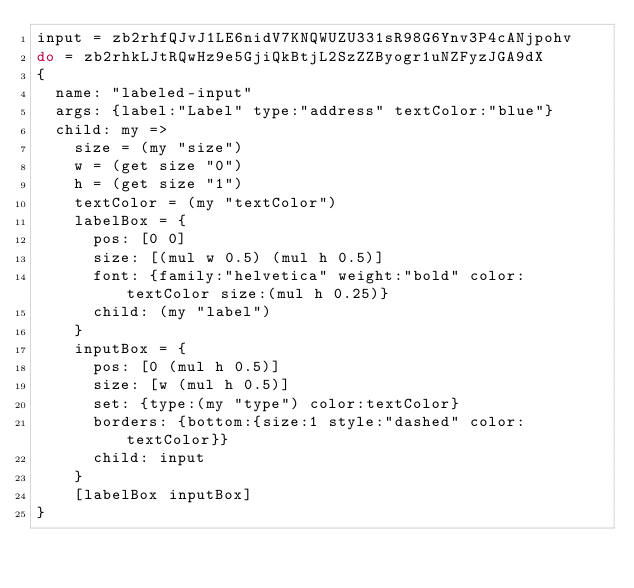<code> <loc_0><loc_0><loc_500><loc_500><_MoonScript_>input = zb2rhfQJvJ1LE6nidV7KNQWUZU331sR98G6Ynv3P4cANjpohv
do = zb2rhkLJtRQwHz9e5GjiQkBtjL2SzZZByogr1uNZFyzJGA9dX
{
  name: "labeled-input"
  args: {label:"Label" type:"address" textColor:"blue"}
  child: my =>
    size = (my "size")
    w = (get size "0")
    h = (get size "1")
    textColor = (my "textColor")
    labelBox = {
      pos: [0 0]
      size: [(mul w 0.5) (mul h 0.5)]
      font: {family:"helvetica" weight:"bold" color:textColor size:(mul h 0.25)}
      child: (my "label")
    }
    inputBox = {
      pos: [0 (mul h 0.5)]
      size: [w (mul h 0.5)]
      set: {type:(my "type") color:textColor}
      borders: {bottom:{size:1 style:"dashed" color:textColor}}
      child: input
    }
    [labelBox inputBox]
}
</code> 